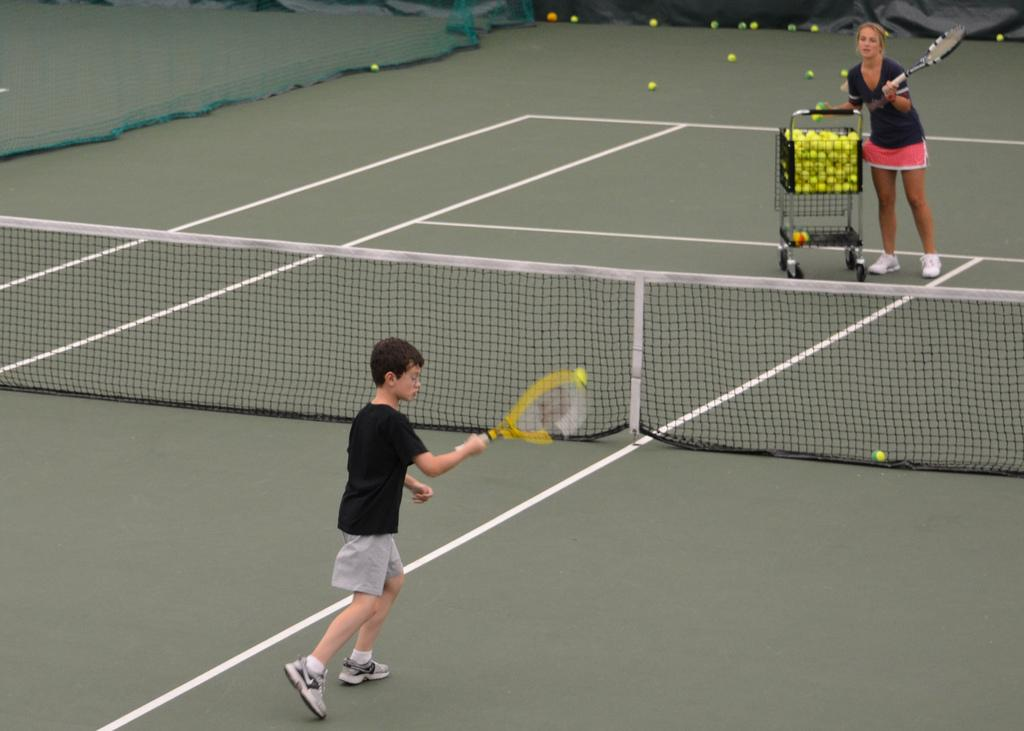How many people are in the image? There are two people in the image. What are the people doing in the image? The people are standing on the ground and holding tennis rackets. What equipment is necessary for the activity they are engaged in? There is a net, tennis rackets, and balls in the image. What additional object can be seen in the image? There is a trolley in the image. What is visible in the background of the image? There is a fence in the background of the image. How many frogs are jumping on the tennis rackets in the image? There are no frogs present in the image; it features two people holding tennis rackets. What type of underwear is the person on the left wearing in the image? There is no information about the person's underwear in the image, as it is not visible or mentioned in the provided facts. 